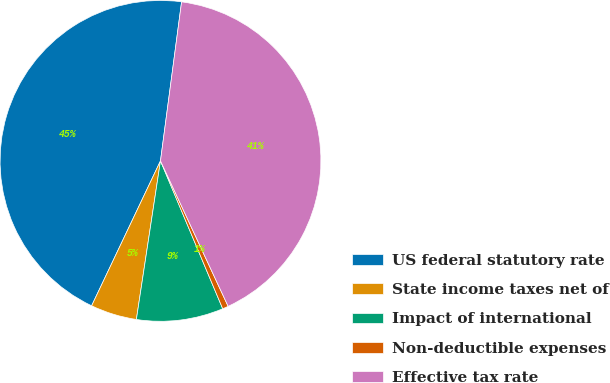<chart> <loc_0><loc_0><loc_500><loc_500><pie_chart><fcel>US federal statutory rate<fcel>State income taxes net of<fcel>Impact of international<fcel>Non-deductible expenses<fcel>Effective tax rate<nl><fcel>45.04%<fcel>4.66%<fcel>8.74%<fcel>0.59%<fcel>40.97%<nl></chart> 